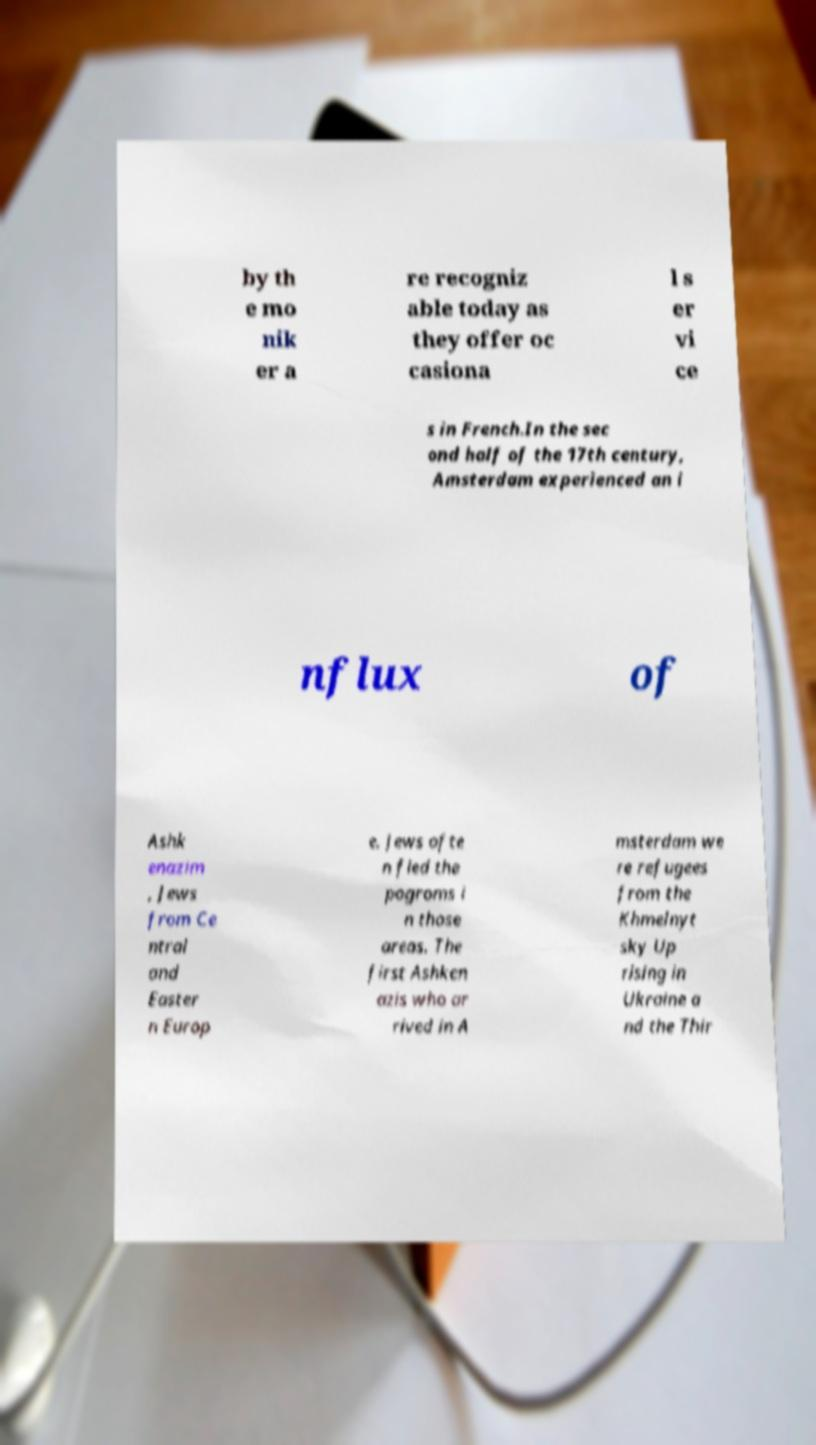There's text embedded in this image that I need extracted. Can you transcribe it verbatim? by th e mo nik er a re recogniz able today as they offer oc casiona l s er vi ce s in French.In the sec ond half of the 17th century, Amsterdam experienced an i nflux of Ashk enazim , Jews from Ce ntral and Easter n Europ e. Jews ofte n fled the pogroms i n those areas. The first Ashken azis who ar rived in A msterdam we re refugees from the Khmelnyt sky Up rising in Ukraine a nd the Thir 